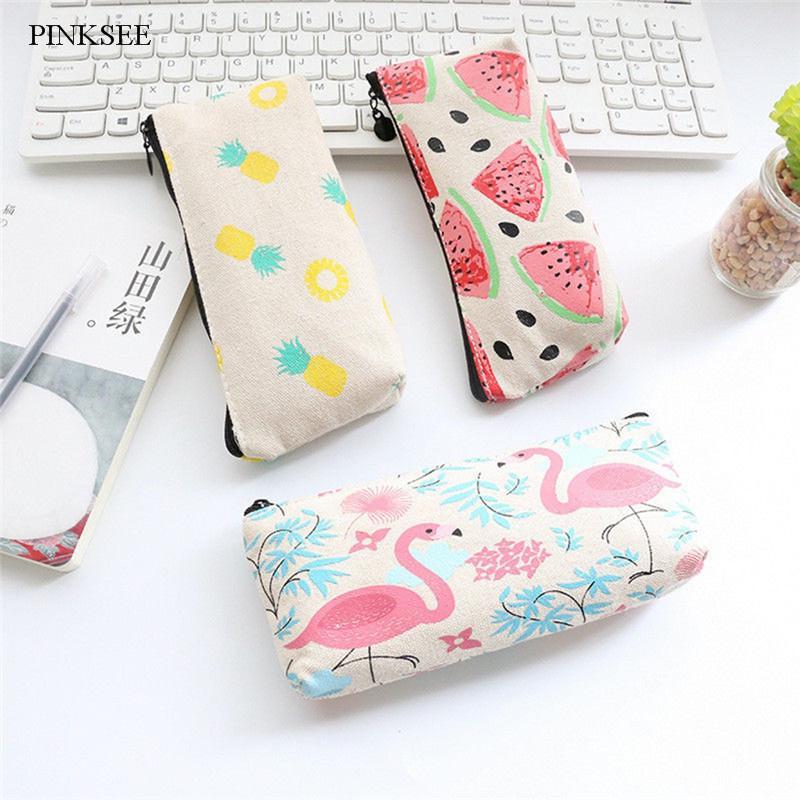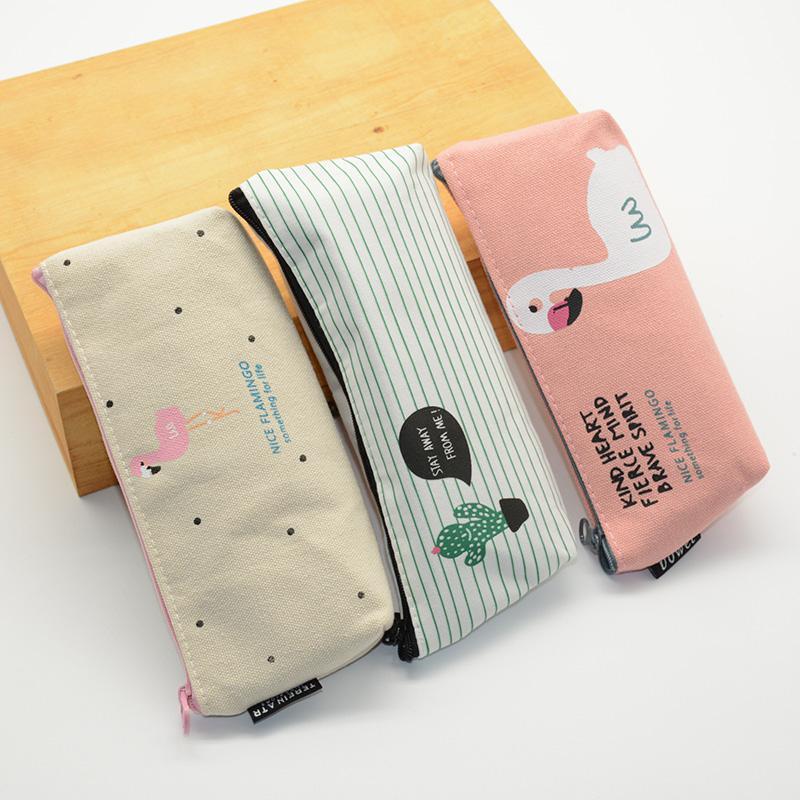The first image is the image on the left, the second image is the image on the right. Examine the images to the left and right. Is the description "there is a pencil pouch with flamingos and flowers on it" accurate? Answer yes or no. Yes. The first image is the image on the left, the second image is the image on the right. For the images shown, is this caption "A pencil case in one image is multicolored with a top zipper, while four zippered cases in the second image are a different style." true? Answer yes or no. No. 